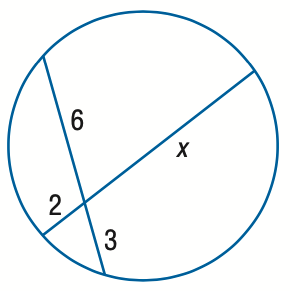Answer the mathemtical geometry problem and directly provide the correct option letter.
Question: Find x. Assume that segments that appear to be tangent are tangent.
Choices: A: 6 B: 7 C: 8 D: 9 D 